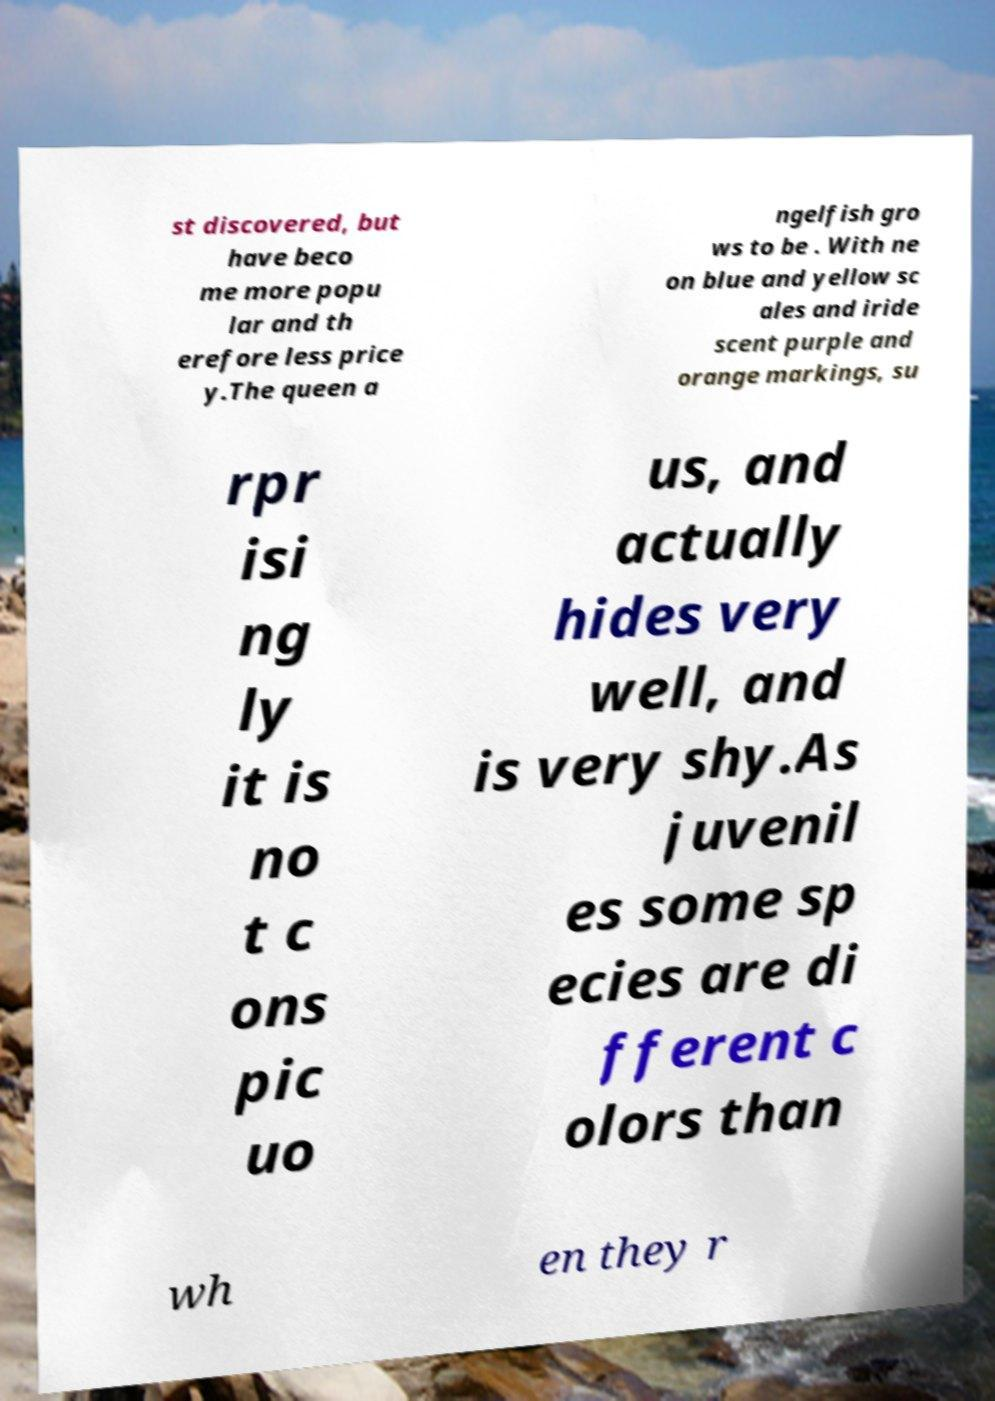What messages or text are displayed in this image? I need them in a readable, typed format. st discovered, but have beco me more popu lar and th erefore less price y.The queen a ngelfish gro ws to be . With ne on blue and yellow sc ales and iride scent purple and orange markings, su rpr isi ng ly it is no t c ons pic uo us, and actually hides very well, and is very shy.As juvenil es some sp ecies are di fferent c olors than wh en they r 